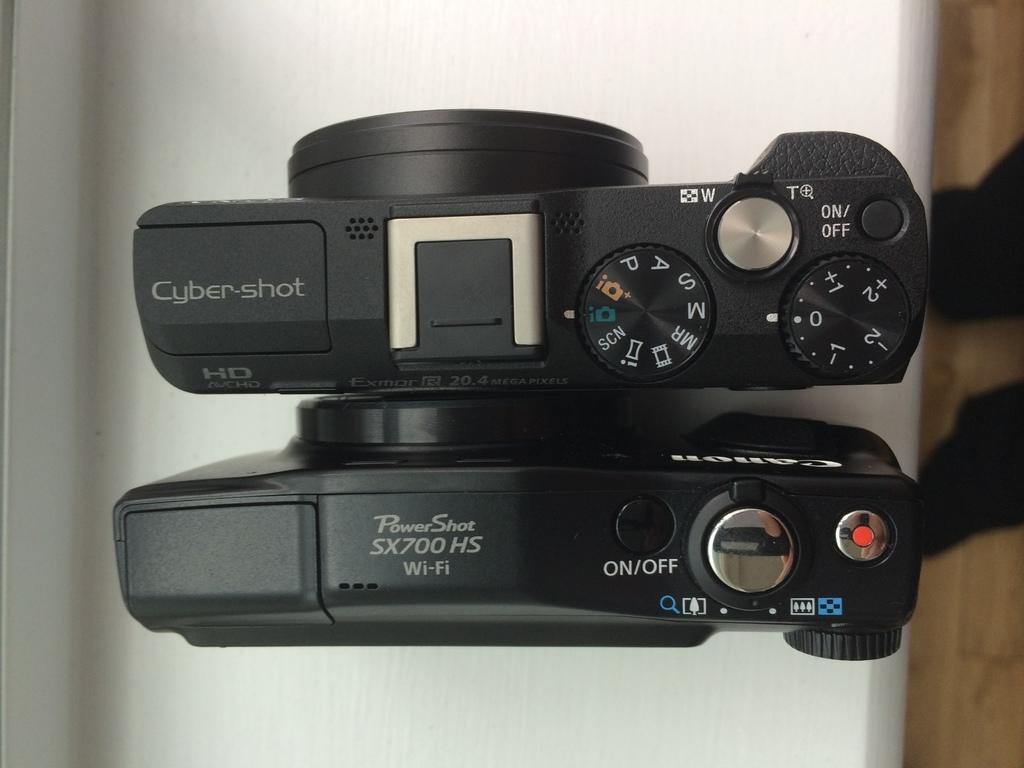<image>
Write a terse but informative summary of the picture. A cybershot camera and powershot camera sit next to each other on a table. 